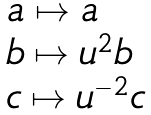Convert formula to latex. <formula><loc_0><loc_0><loc_500><loc_500>\begin{array} { l } a \mapsto a \\ b \mapsto u ^ { 2 } b \\ c \mapsto u ^ { - 2 } c \end{array}</formula> 